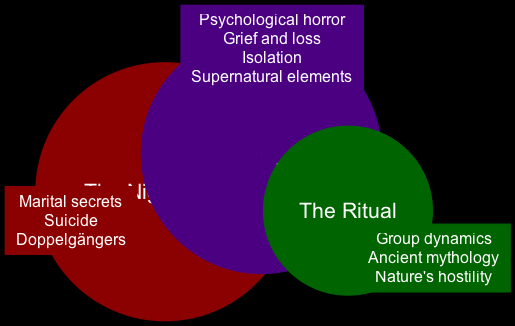What are the themes specific to "The Night House"? The themes listed under "The Night House" node are "Marital secrets," "Suicide," and "Doppelgängers."
Answer: Marital secrets, Suicide, Doppelgängers How many overlapping themes are there? The overlapping themes are listed in the center of the Venn diagram, and there are four themes: "Psychological horror," "Grief and loss," "Isolation," and "Supernatural elements."
Answer: 4 What unique theme is found in "The Ritual" that is not in "The Night House"? The unique themes listed for "The Ritual" are "Group dynamics," "Ancient mythology," and "Nature's hostility." Among these, any of them could serve as an answer. "Group dynamics" is a valid specific answer.
Answer: Group dynamics Which theme connects both films? The overlapping themes in the center of the diagram connect both films. One of these is "Psychological horror," which is present in both films' themes.
Answer: Psychological horror How many themes does "The Night House" have compared to "The Ritual"? "The Night House" has three specific themes listed, whereas "The Ritual" has three unique themes listed. Both films have an equal number of total themes.
Answer: Equal number What color represents "The Night House" theme in the diagram? The color associated with "The Night House" node is dark red (#8B0000), which represents its unique themes.
Answer: Dark red What are the supernatural elements that overlap between the two films? The diagram indicates that "Supernatural elements" is one of the overlapping themes; however, it does not provide details about what those elements are. Thus, the answer touches on the presence rather than specifics.
Answer: Supernatural elements Which theme reflects a societal aspect in either film? "Group dynamics," found under "The Ritual," reflects societal aspects and is exclusive to that film, which showcases how humans interact within a group setting.
Answer: Group dynamics 